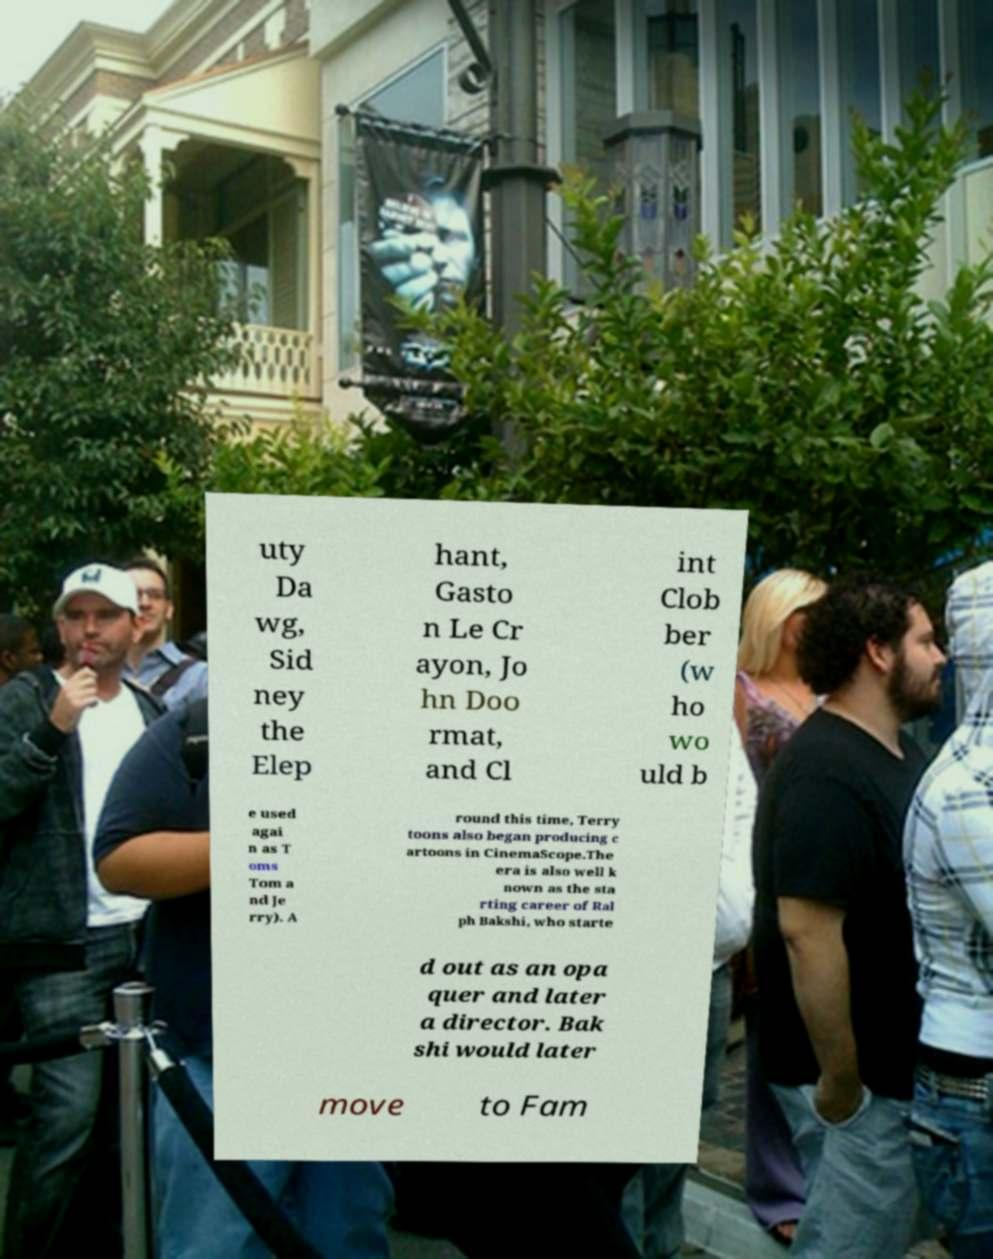Could you assist in decoding the text presented in this image and type it out clearly? uty Da wg, Sid ney the Elep hant, Gasto n Le Cr ayon, Jo hn Doo rmat, and Cl int Clob ber (w ho wo uld b e used agai n as T oms Tom a nd Je rry). A round this time, Terry toons also began producing c artoons in CinemaScope.The era is also well k nown as the sta rting career of Ral ph Bakshi, who starte d out as an opa quer and later a director. Bak shi would later move to Fam 